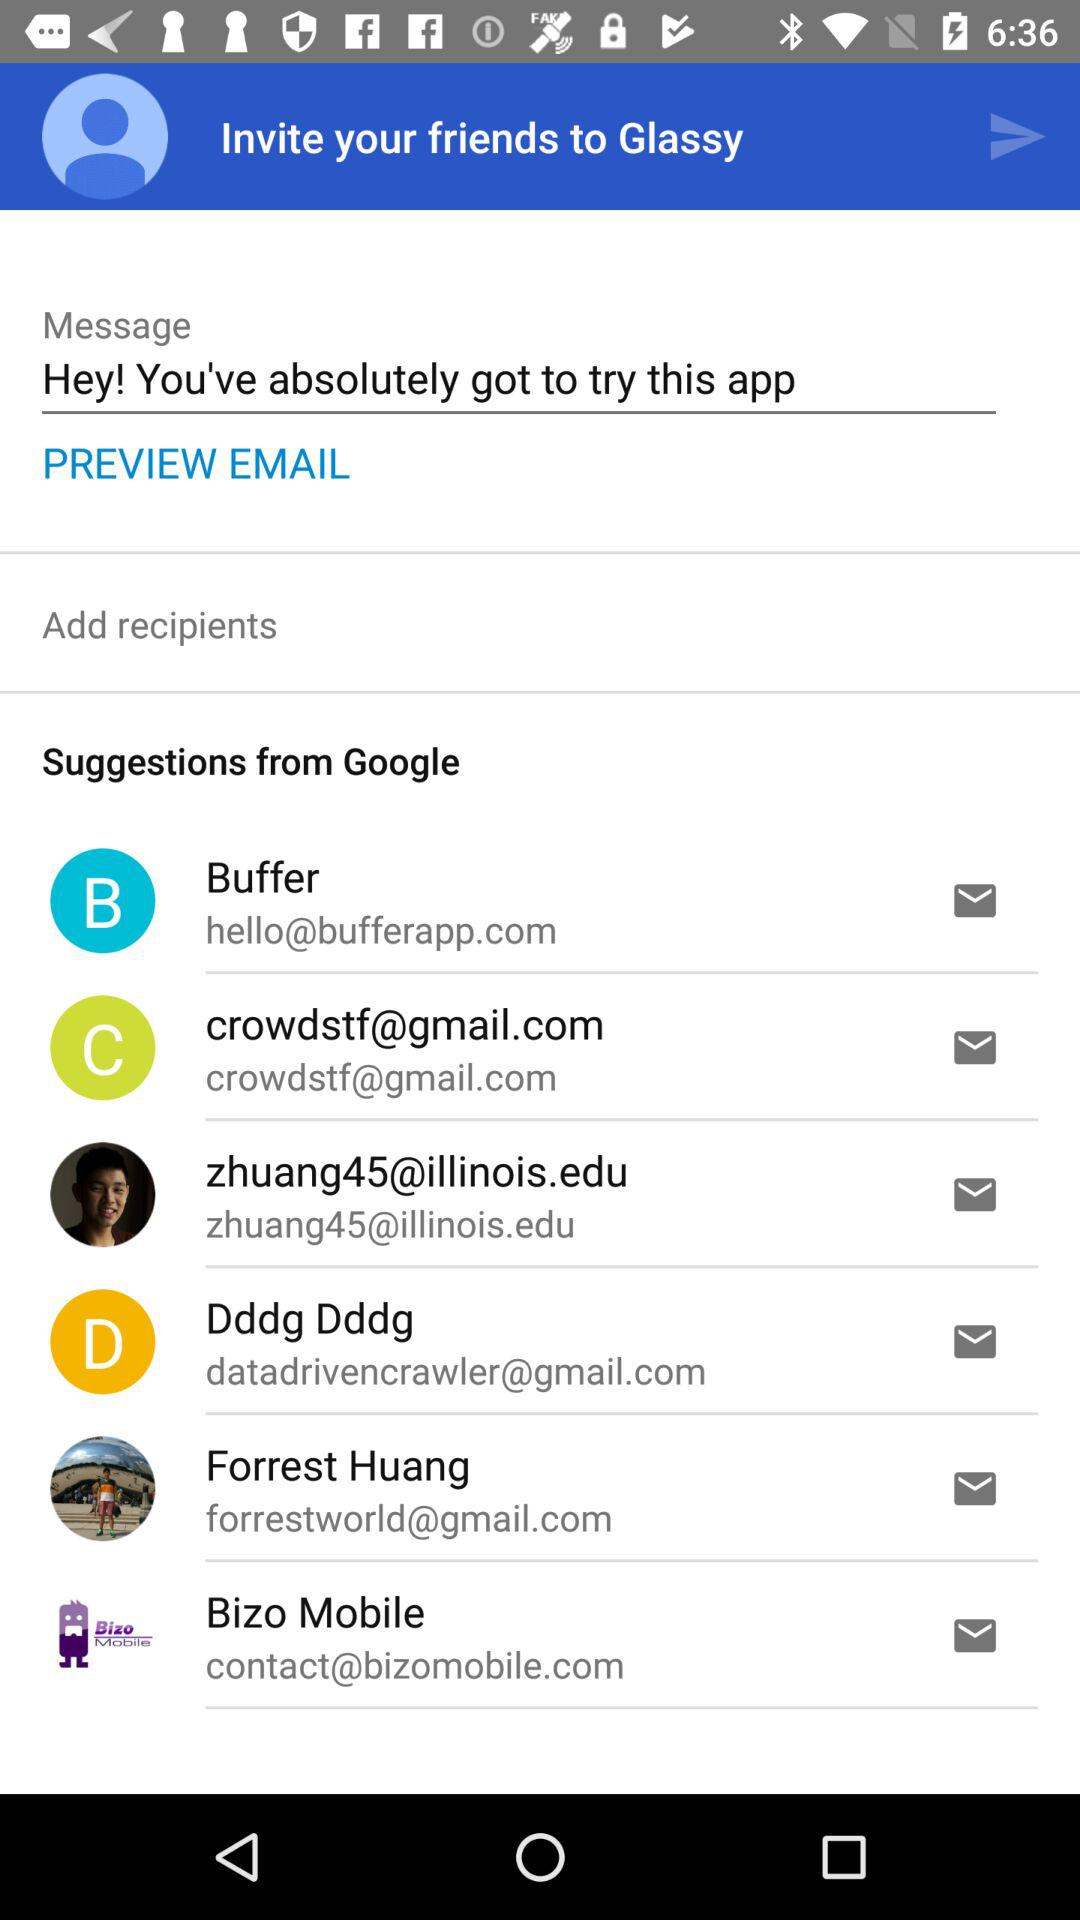What is the given message? The given message is "Hey! You've absolutely got to try this app". 